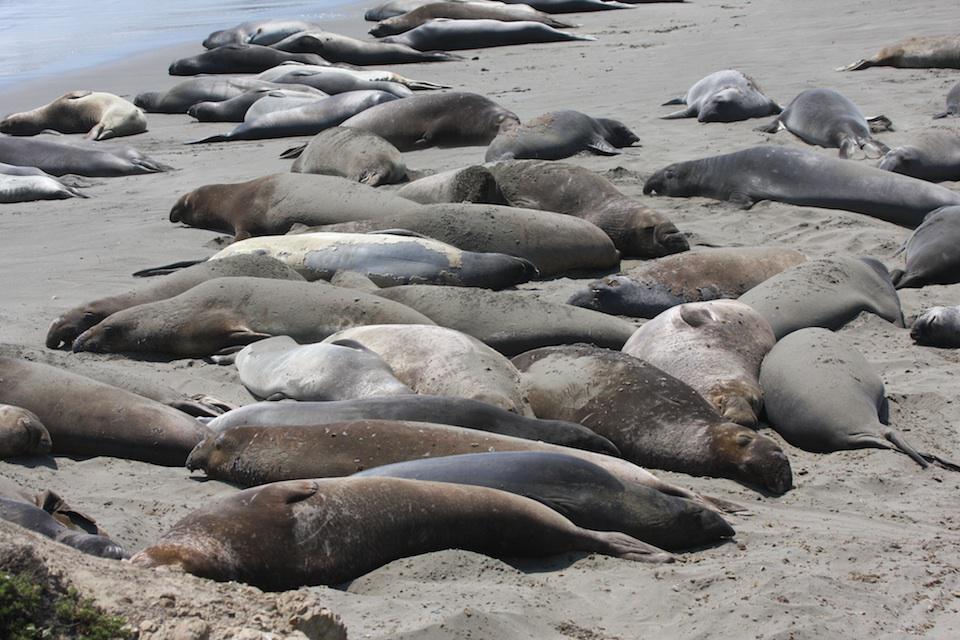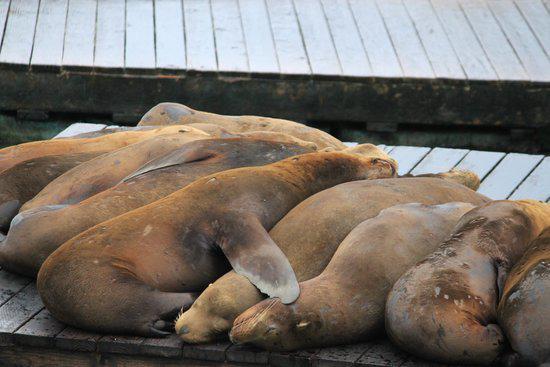The first image is the image on the left, the second image is the image on the right. Considering the images on both sides, is "An image shows a mass of seals lying on a structure made of wooden planks." valid? Answer yes or no. Yes. 